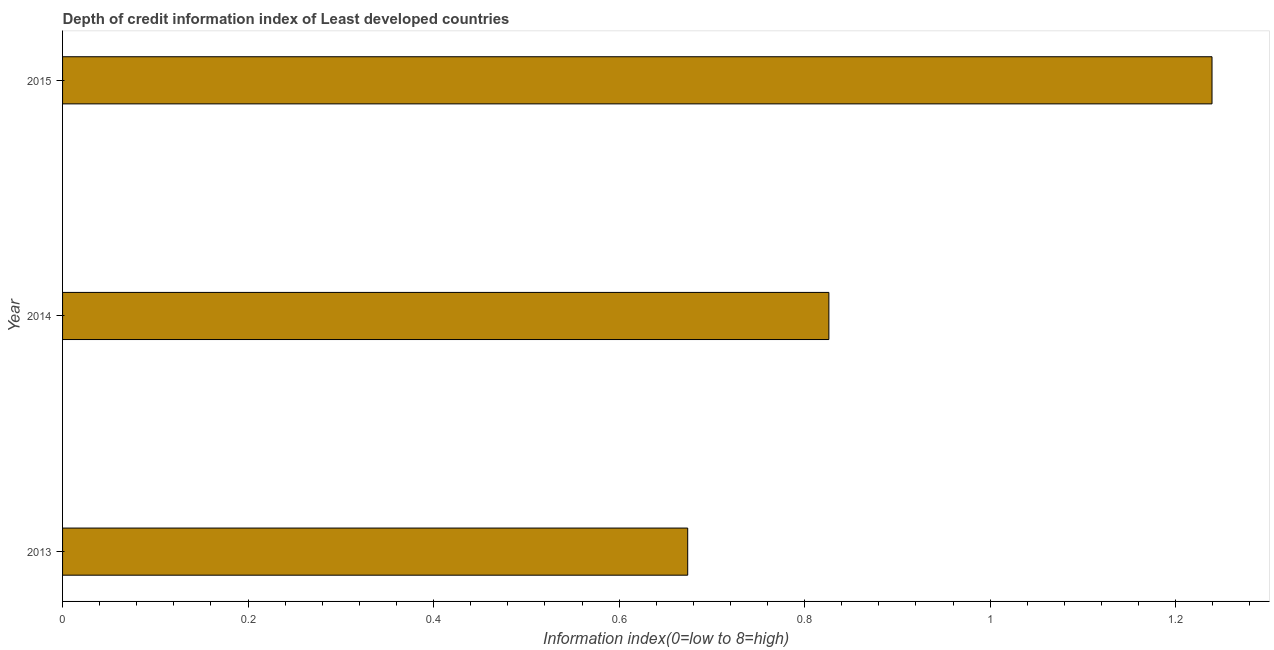What is the title of the graph?
Your response must be concise. Depth of credit information index of Least developed countries. What is the label or title of the X-axis?
Keep it short and to the point. Information index(0=low to 8=high). What is the depth of credit information index in 2015?
Ensure brevity in your answer.  1.24. Across all years, what is the maximum depth of credit information index?
Keep it short and to the point. 1.24. Across all years, what is the minimum depth of credit information index?
Give a very brief answer. 0.67. In which year was the depth of credit information index maximum?
Make the answer very short. 2015. What is the sum of the depth of credit information index?
Your response must be concise. 2.74. What is the difference between the depth of credit information index in 2013 and 2014?
Offer a terse response. -0.15. What is the median depth of credit information index?
Make the answer very short. 0.83. What is the ratio of the depth of credit information index in 2014 to that in 2015?
Your answer should be compact. 0.67. Is the depth of credit information index in 2014 less than that in 2015?
Your answer should be compact. Yes. Is the difference between the depth of credit information index in 2013 and 2015 greater than the difference between any two years?
Keep it short and to the point. Yes. What is the difference between the highest and the second highest depth of credit information index?
Ensure brevity in your answer.  0.41. What is the difference between the highest and the lowest depth of credit information index?
Offer a terse response. 0.57. In how many years, is the depth of credit information index greater than the average depth of credit information index taken over all years?
Provide a short and direct response. 1. Are all the bars in the graph horizontal?
Offer a very short reply. Yes. How many years are there in the graph?
Offer a very short reply. 3. What is the difference between two consecutive major ticks on the X-axis?
Keep it short and to the point. 0.2. What is the Information index(0=low to 8=high) in 2013?
Your answer should be compact. 0.67. What is the Information index(0=low to 8=high) in 2014?
Provide a short and direct response. 0.83. What is the Information index(0=low to 8=high) in 2015?
Ensure brevity in your answer.  1.24. What is the difference between the Information index(0=low to 8=high) in 2013 and 2014?
Provide a succinct answer. -0.15. What is the difference between the Information index(0=low to 8=high) in 2013 and 2015?
Provide a succinct answer. -0.57. What is the difference between the Information index(0=low to 8=high) in 2014 and 2015?
Your response must be concise. -0.41. What is the ratio of the Information index(0=low to 8=high) in 2013 to that in 2014?
Ensure brevity in your answer.  0.82. What is the ratio of the Information index(0=low to 8=high) in 2013 to that in 2015?
Keep it short and to the point. 0.54. What is the ratio of the Information index(0=low to 8=high) in 2014 to that in 2015?
Your answer should be very brief. 0.67. 